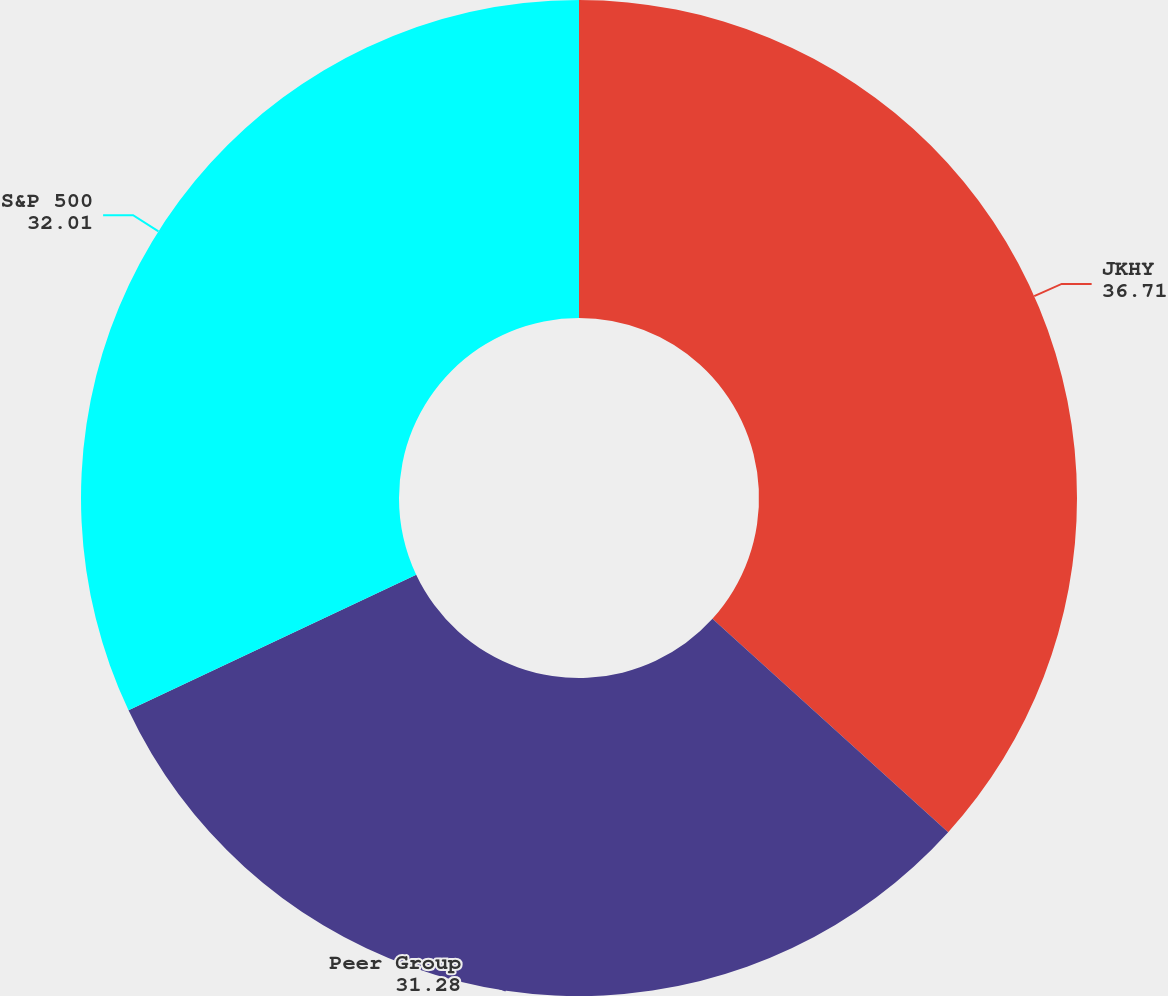Convert chart to OTSL. <chart><loc_0><loc_0><loc_500><loc_500><pie_chart><fcel>JKHY<fcel>Peer Group<fcel>S&P 500<nl><fcel>36.71%<fcel>31.28%<fcel>32.01%<nl></chart> 